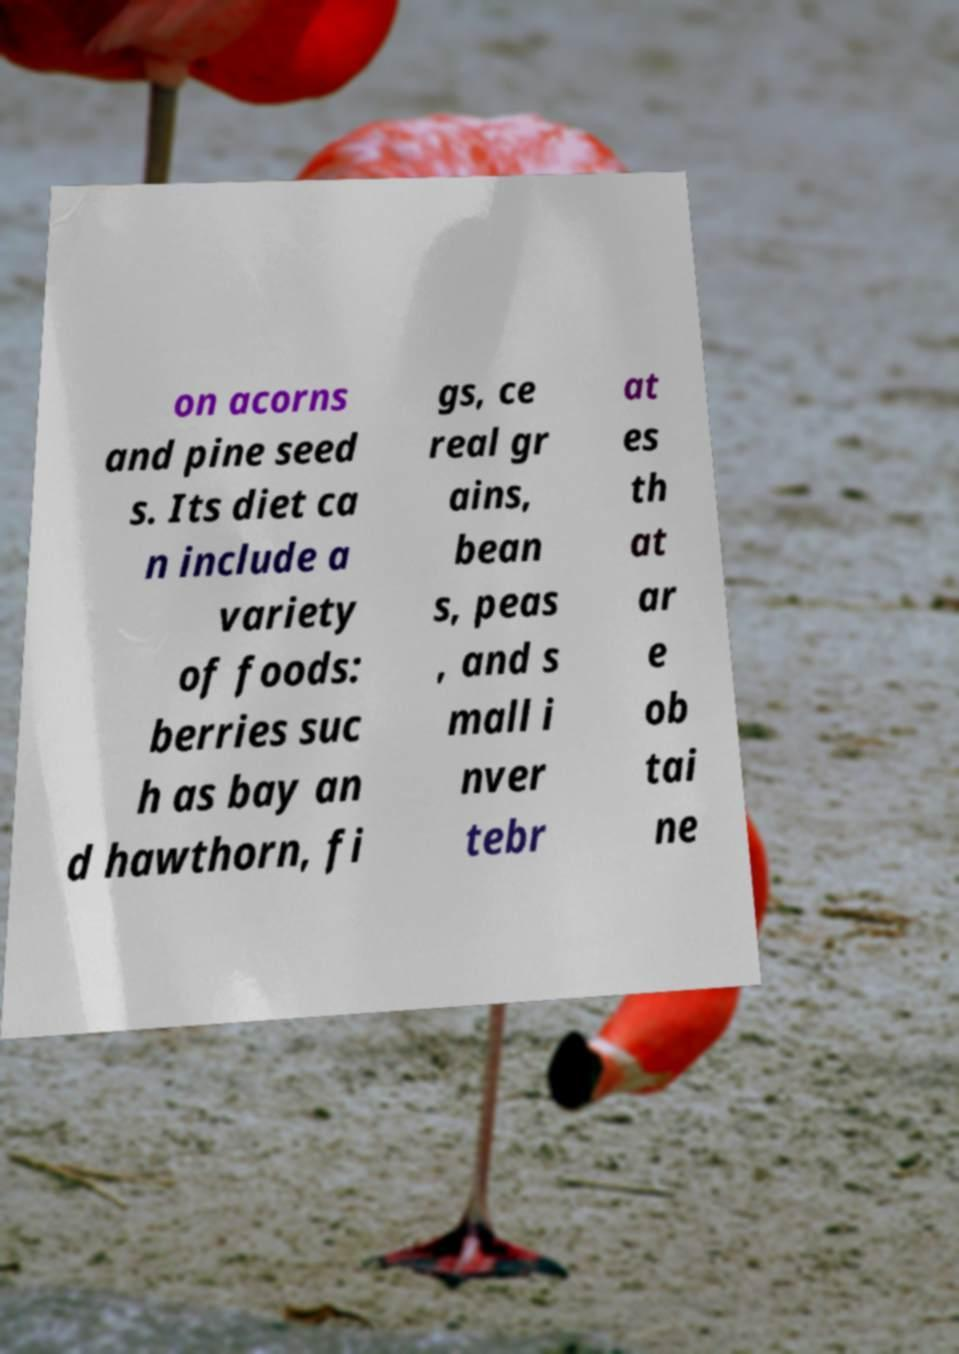I need the written content from this picture converted into text. Can you do that? on acorns and pine seed s. Its diet ca n include a variety of foods: berries suc h as bay an d hawthorn, fi gs, ce real gr ains, bean s, peas , and s mall i nver tebr at es th at ar e ob tai ne 